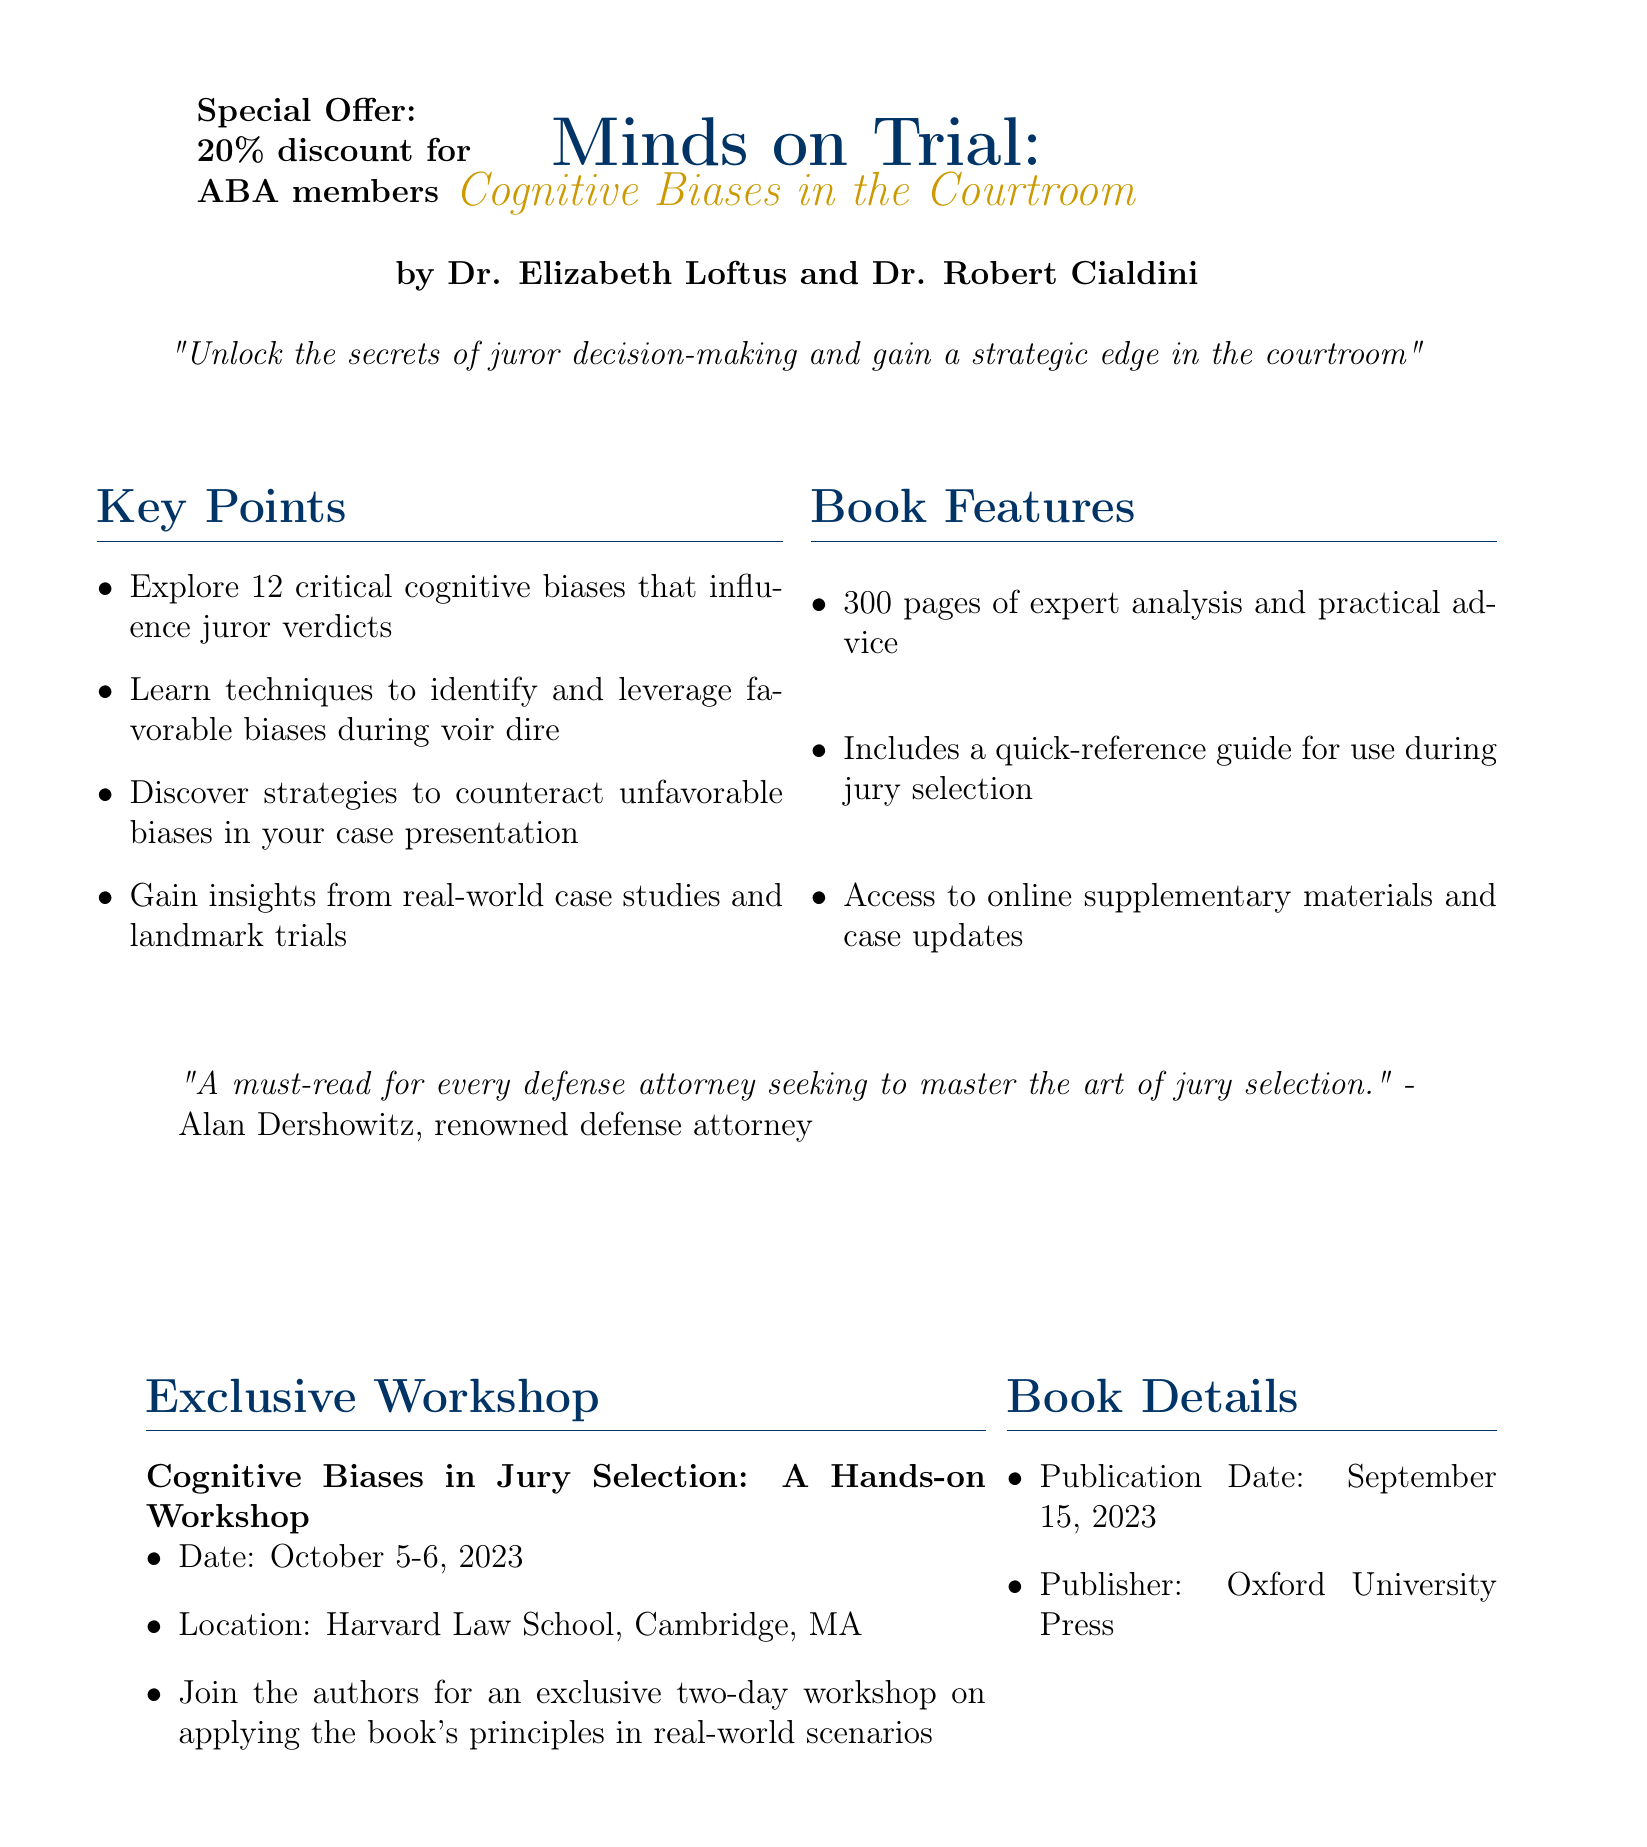What is the title of the book? The title is explicitly mentioned in the document as "Minds on Trial: Cognitive Biases in the Courtroom."
Answer: Minds on Trial: Cognitive Biases in the Courtroom Who are the authors of the book? The authors are listed in the introductory section of the document as Dr. Elizabeth Loftus and Dr. Robert Cialdini.
Answer: Dr. Elizabeth Loftus and Dr. Robert Cialdini What is the publication date of the book? The publication date is stated clearly in the document as September 15, 2023.
Answer: September 15, 2023 What special offer is mentioned for the book? The document mentions a special offer that grants a 20% discount for members of the American Bar Association.
Answer: 20% discount for ABA members When is the workshop on cognitive biases scheduled? The workshop date is detailed in the seminar information section as October 5-6, 2023.
Answer: October 5-6, 2023 What is the main benefit described for defense attorneys reading this book? The book is endorsed as a must-read for defense attorneys seeking to master jury selection.
Answer: To master the art of jury selection How many critical cognitive biases are explored in the book? The document specifically states that the book explores 12 critical cognitive biases.
Answer: 12 Where will the workshop take place? The location of the workshop is indicated in the document as Harvard Law School, Cambridge, MA.
Answer: Harvard Law School, Cambridge, MA What publisher released the book? The publisher is mentioned in the book details section as Oxford University Press.
Answer: Oxford University Press 